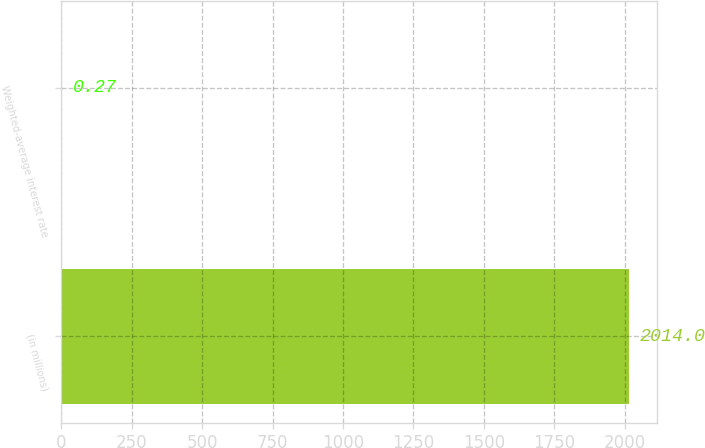Convert chart to OTSL. <chart><loc_0><loc_0><loc_500><loc_500><bar_chart><fcel>(in millions)<fcel>Weighted-average interest rate<nl><fcel>2014<fcel>0.27<nl></chart> 